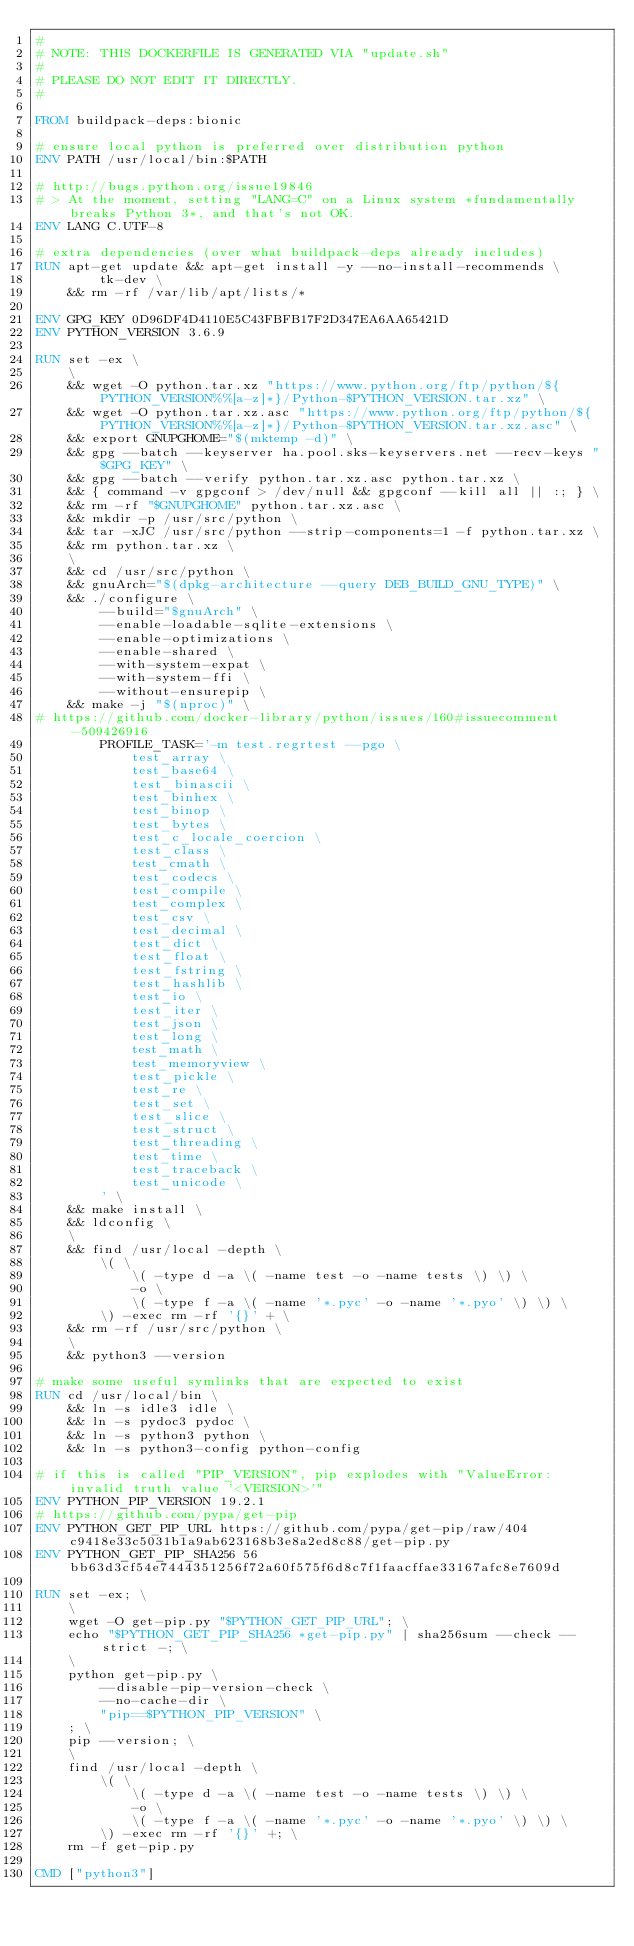<code> <loc_0><loc_0><loc_500><loc_500><_Dockerfile_>#
# NOTE: THIS DOCKERFILE IS GENERATED VIA "update.sh"
#
# PLEASE DO NOT EDIT IT DIRECTLY.
#

FROM buildpack-deps:bionic

# ensure local python is preferred over distribution python
ENV PATH /usr/local/bin:$PATH

# http://bugs.python.org/issue19846
# > At the moment, setting "LANG=C" on a Linux system *fundamentally breaks Python 3*, and that's not OK.
ENV LANG C.UTF-8

# extra dependencies (over what buildpack-deps already includes)
RUN apt-get update && apt-get install -y --no-install-recommends \
        tk-dev \
    && rm -rf /var/lib/apt/lists/*

ENV GPG_KEY 0D96DF4D4110E5C43FBFB17F2D347EA6AA65421D
ENV PYTHON_VERSION 3.6.9

RUN set -ex \
    \
    && wget -O python.tar.xz "https://www.python.org/ftp/python/${PYTHON_VERSION%%[a-z]*}/Python-$PYTHON_VERSION.tar.xz" \
    && wget -O python.tar.xz.asc "https://www.python.org/ftp/python/${PYTHON_VERSION%%[a-z]*}/Python-$PYTHON_VERSION.tar.xz.asc" \
    && export GNUPGHOME="$(mktemp -d)" \
    && gpg --batch --keyserver ha.pool.sks-keyservers.net --recv-keys "$GPG_KEY" \
    && gpg --batch --verify python.tar.xz.asc python.tar.xz \
    && { command -v gpgconf > /dev/null && gpgconf --kill all || :; } \
    && rm -rf "$GNUPGHOME" python.tar.xz.asc \
    && mkdir -p /usr/src/python \
    && tar -xJC /usr/src/python --strip-components=1 -f python.tar.xz \
    && rm python.tar.xz \
    \
    && cd /usr/src/python \
    && gnuArch="$(dpkg-architecture --query DEB_BUILD_GNU_TYPE)" \
    && ./configure \
        --build="$gnuArch" \
        --enable-loadable-sqlite-extensions \
        --enable-optimizations \
        --enable-shared \
        --with-system-expat \
        --with-system-ffi \
        --without-ensurepip \
    && make -j "$(nproc)" \
# https://github.com/docker-library/python/issues/160#issuecomment-509426916
        PROFILE_TASK='-m test.regrtest --pgo \
            test_array \
            test_base64 \
            test_binascii \
            test_binhex \
            test_binop \
            test_bytes \
            test_c_locale_coercion \
            test_class \
            test_cmath \
            test_codecs \
            test_compile \
            test_complex \
            test_csv \
            test_decimal \
            test_dict \
            test_float \
            test_fstring \
            test_hashlib \
            test_io \
            test_iter \
            test_json \
            test_long \
            test_math \
            test_memoryview \
            test_pickle \
            test_re \
            test_set \
            test_slice \
            test_struct \
            test_threading \
            test_time \
            test_traceback \
            test_unicode \
        ' \
    && make install \
    && ldconfig \
    \
    && find /usr/local -depth \
        \( \
            \( -type d -a \( -name test -o -name tests \) \) \
            -o \
            \( -type f -a \( -name '*.pyc' -o -name '*.pyo' \) \) \
        \) -exec rm -rf '{}' + \
    && rm -rf /usr/src/python \
    \
    && python3 --version

# make some useful symlinks that are expected to exist
RUN cd /usr/local/bin \
    && ln -s idle3 idle \
    && ln -s pydoc3 pydoc \
    && ln -s python3 python \
    && ln -s python3-config python-config

# if this is called "PIP_VERSION", pip explodes with "ValueError: invalid truth value '<VERSION>'"
ENV PYTHON_PIP_VERSION 19.2.1
# https://github.com/pypa/get-pip
ENV PYTHON_GET_PIP_URL https://github.com/pypa/get-pip/raw/404c9418e33c5031b1a9ab623168b3e8a2ed8c88/get-pip.py
ENV PYTHON_GET_PIP_SHA256 56bb63d3cf54e7444351256f72a60f575f6d8c7f1faacffae33167afc8e7609d

RUN set -ex; \
    \
    wget -O get-pip.py "$PYTHON_GET_PIP_URL"; \
    echo "$PYTHON_GET_PIP_SHA256 *get-pip.py" | sha256sum --check --strict -; \
    \
    python get-pip.py \
        --disable-pip-version-check \
        --no-cache-dir \
        "pip==$PYTHON_PIP_VERSION" \
    ; \
    pip --version; \
    \
    find /usr/local -depth \
        \( \
            \( -type d -a \( -name test -o -name tests \) \) \
            -o \
            \( -type f -a \( -name '*.pyc' -o -name '*.pyo' \) \) \
        \) -exec rm -rf '{}' +; \
    rm -f get-pip.py

CMD ["python3"]</code> 